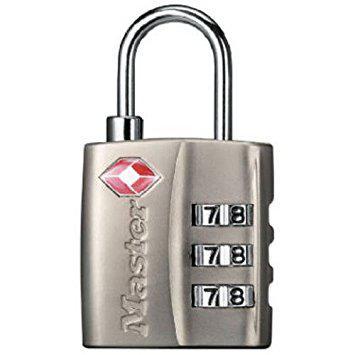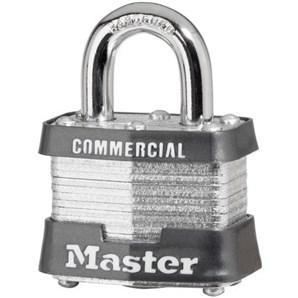The first image is the image on the left, the second image is the image on the right. Analyze the images presented: Is the assertion "An image features exactly one combination lock, which is black." valid? Answer yes or no. No. The first image is the image on the left, the second image is the image on the right. Examine the images to the left and right. Is the description "All locks have a loop on the top and exactly three rows of number belts on the front of the lock." accurate? Answer yes or no. No. 